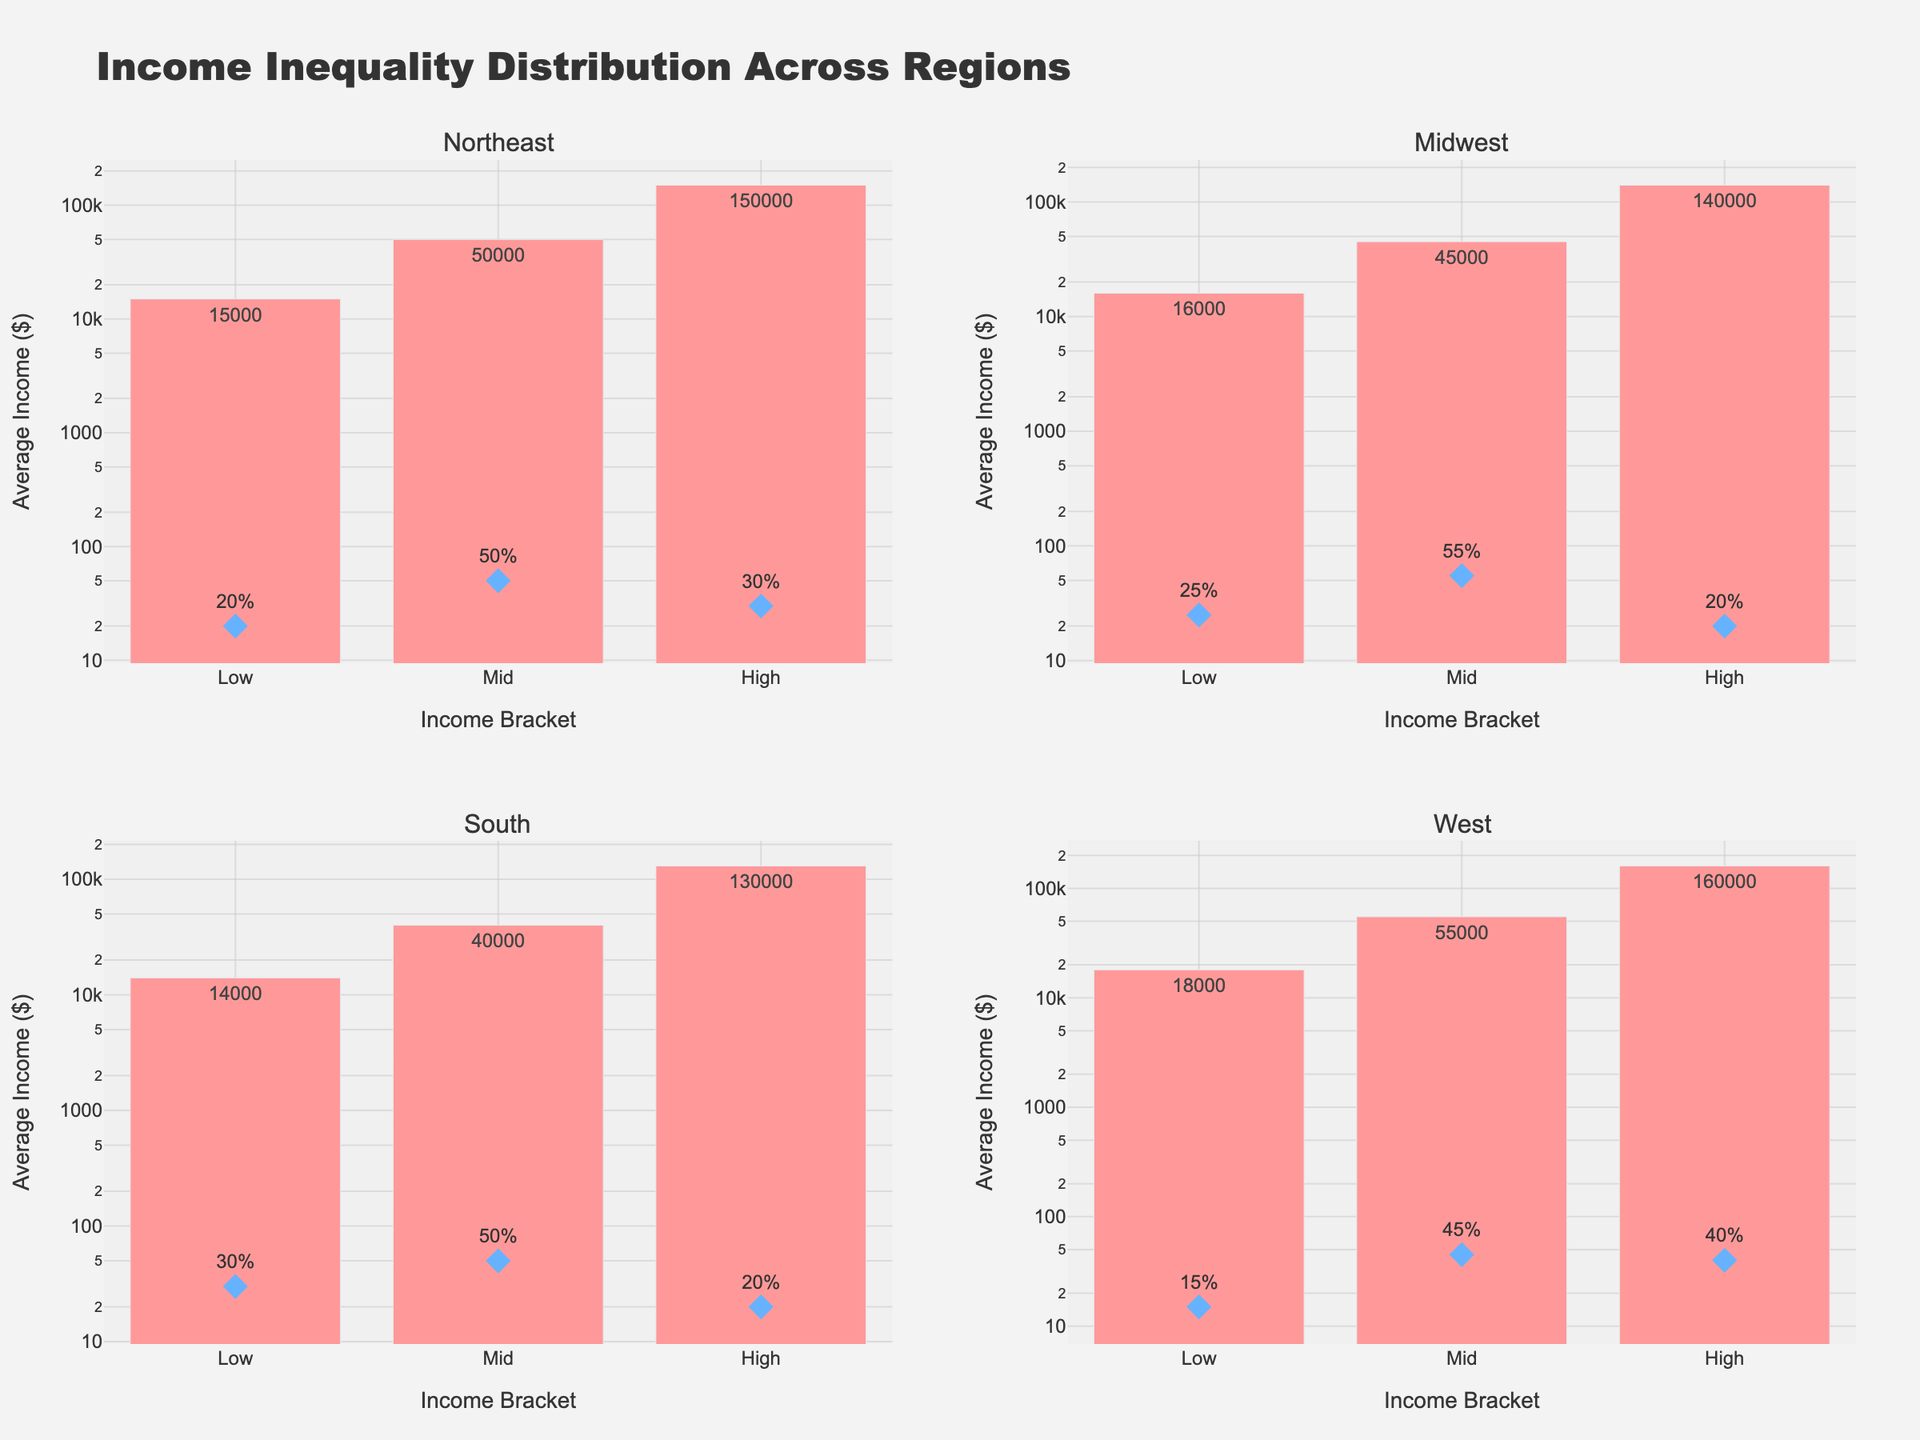What is the title of the plot? The title of the plot is located at the top center of the figure and reads "Income Inequality Distribution Across Regions".
Answer: Income Inequality Distribution Across Regions Which region has the highest average income in the 'High' income bracket? By looking at the height of the bars representing the 'High' income bracket in all regions, the West has the highest average income, with the bar reaching up to $160,000.
Answer: West What is the percentage of the population in the 'Low' income bracket in the South? The scatter plot markers represent the percentage of the population. By looking at the marker for the 'Low' income bracket in the South subplot, it shows 30%.
Answer: 30% Compare the average income of the 'Mid' income bracket between the Midwest and the South. Which one is higher? The bars for the 'Mid' income bracket can be compared. In the Midwest, the bar reaches $45,000, while in the South, the bar reaches $40,000. Therefore, the Midwest has a higher average income.
Answer: Midwest What is the combined percentage of the population in the 'High' income bracket for the Northeast and Midwest regions? Add the percentage of the population for the 'High' income bracket in both regions: Northeast (30%) + Midwest (20%) = 50%.
Answer: 50% Which region has the lowest average income in the 'Low' income bracket, and what is that value? By comparing the heights of the bars for the 'Low' income bracket across all regions, the South has the lowest average income at $14,000.
Answer: South, 14,000 Is the percentage of the population in the 'High' income bracket greater in the Northeast or the West? By comparing the scatter markers, the West has a marker of 40% and the Northeast has a marker of 30%. Therefore, the West has a greater percentage.
Answer: West Which region's 'Mid' income bracket population percentage is closest to the actual average, and what are those values? Check the scatter markers for the 'Mid' income bracket and compare: Northeast (50%), Midwest (55%), South (50%), and West (45%). The average of these percentages is (50 + 55 + 50 + 45) / 4 = 50%. The Northeast and South are closest with 50%.
Answer: Northeast and South In the Midwest region, how much higher is the average income in the 'High' bracket compared to the 'Mid' bracket? Subtract the average income of the 'Mid' income bracket from the 'High' income bracket for the Midwest: $140,000 - $45,000 = $95,000.
Answer: $95,000 